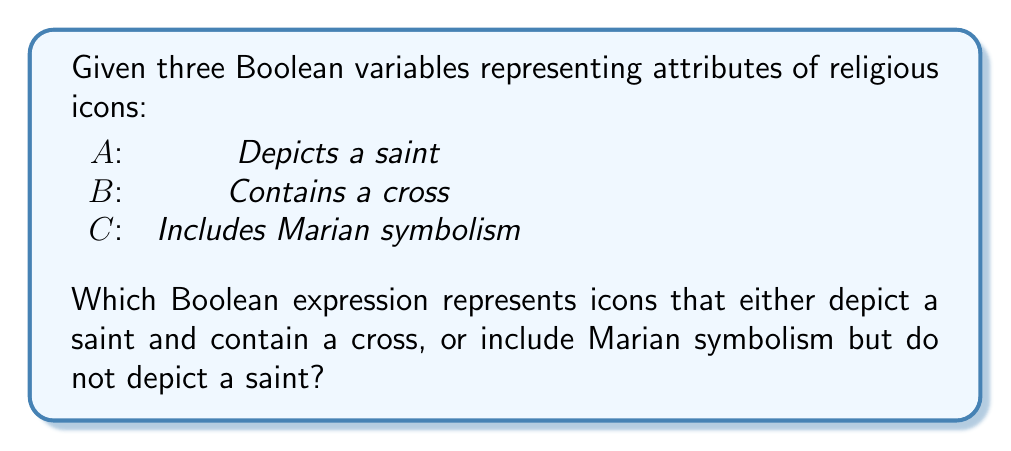Show me your answer to this math problem. Let's approach this step-by-step:

1. First, let's consider the two conditions separately:
   a) Icons that depict a saint and contain a cross
   b) Icons that include Marian symbolism but do not depict a saint

2. For condition (a):
   - Depicts a saint: $A$
   - Contains a cross: $B$
   - Combined: $A \land B$

3. For condition (b):
   - Includes Marian symbolism: $C$
   - Does not depict a saint: $\lnot A$
   - Combined: $C \land \lnot A$

4. Now, we need to combine these two conditions using OR, as we want icons that satisfy either condition:
   $(A \land B) \lor (C \land \lnot A)$

5. This expression represents icons that either:
   - Depict a saint AND contain a cross, OR
   - Include Marian symbolism AND do NOT depict a saint

Therefore, the Boolean expression that represents the desired set of icons is:
$$(A \land B) \lor (C \land \lnot A)$$
Answer: $(A \land B) \lor (C \land \lnot A)$ 